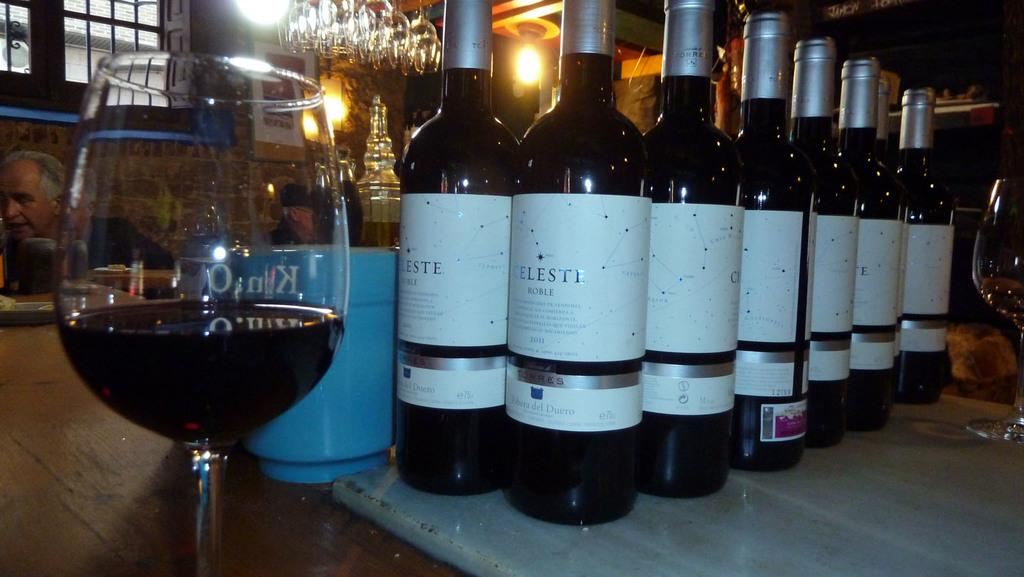<image>
Share a concise interpretation of the image provided. Bottles of wine that say "Celeste" on it behind a cup of wine. 